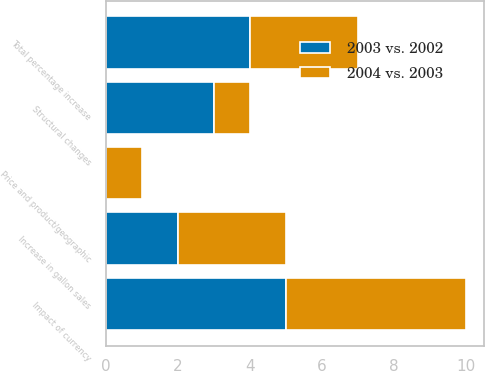Convert chart. <chart><loc_0><loc_0><loc_500><loc_500><stacked_bar_chart><ecel><fcel>Increase in gallon sales<fcel>Structural changes<fcel>Price and product/geographic<fcel>Impact of currency<fcel>Total percentage increase<nl><fcel>2003 vs. 2002<fcel>2<fcel>3<fcel>0<fcel>5<fcel>4<nl><fcel>2004 vs. 2003<fcel>3<fcel>1<fcel>1<fcel>5<fcel>3<nl></chart> 